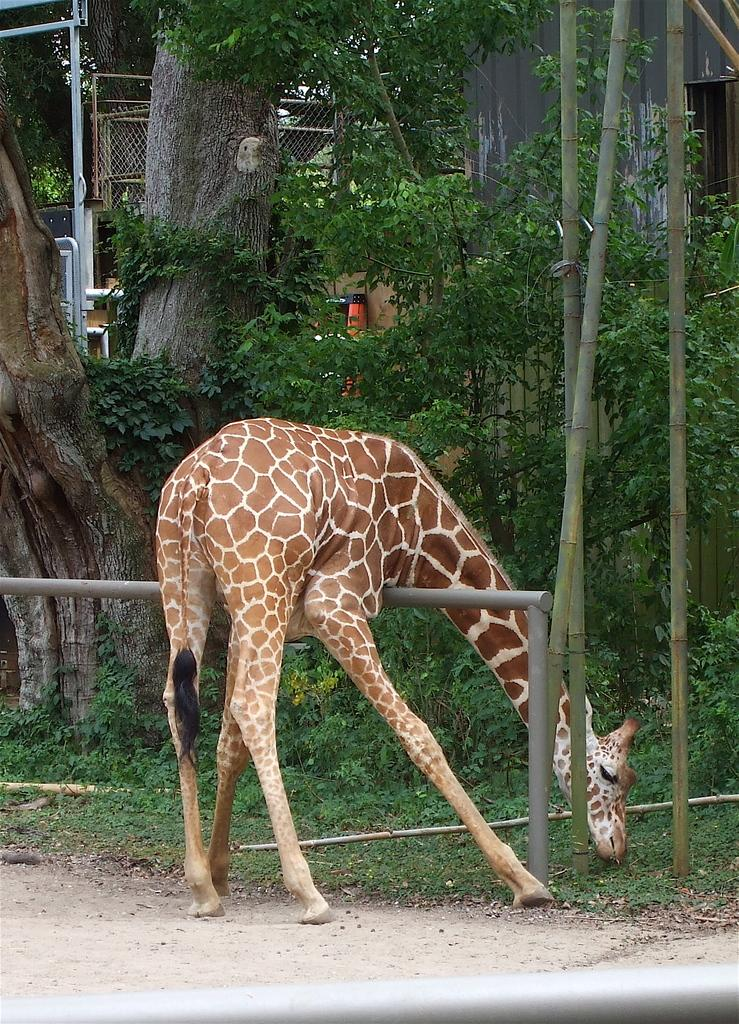What animal can be seen in the image? There is a giraffe in the image. What is the giraffe doing in the image? The giraffe is eating grass. What colors are present on the giraffe? The giraffe is brown and white in color. What can be seen in the background of the image? There are trees and the sky visible in the background of the image. What color are the trees in the image? The trees are green in color. What color is the sky in the image? The sky is white in color. Where is the mom in the image? There is no mom present in the image; it features a giraffe eating grass. What type of tool is being used by the band in the image? There is no band or tool present in the image; it features a giraffe eating grass and a background with trees and a white sky. 